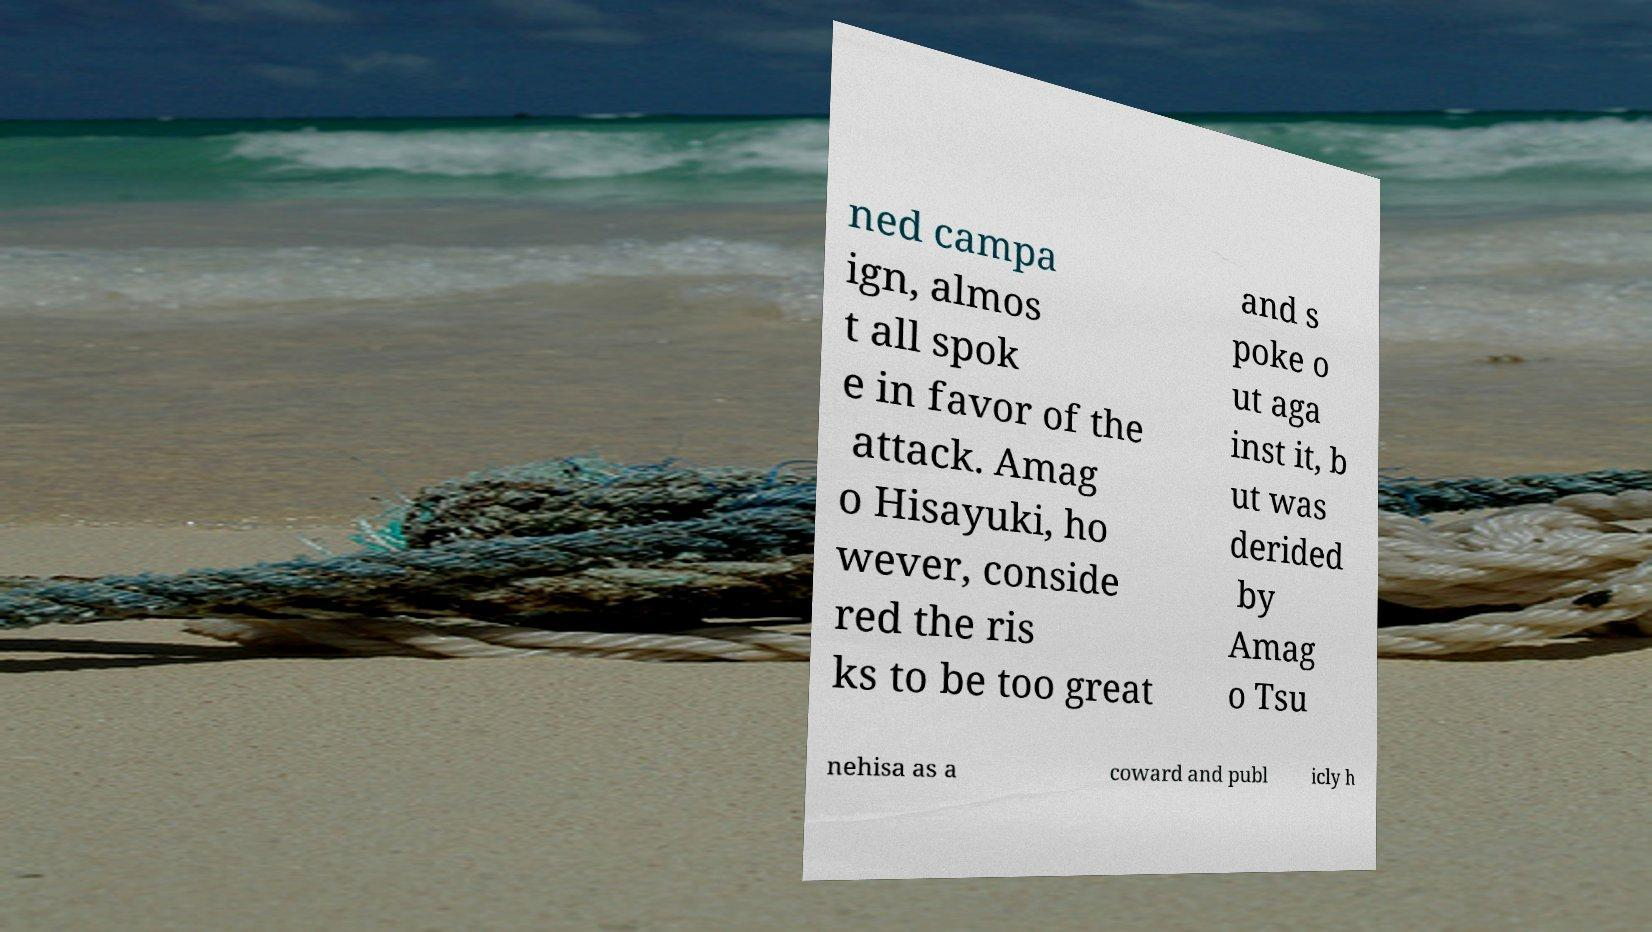Could you extract and type out the text from this image? ned campa ign, almos t all spok e in favor of the attack. Amag o Hisayuki, ho wever, conside red the ris ks to be too great and s poke o ut aga inst it, b ut was derided by Amag o Tsu nehisa as a coward and publ icly h 